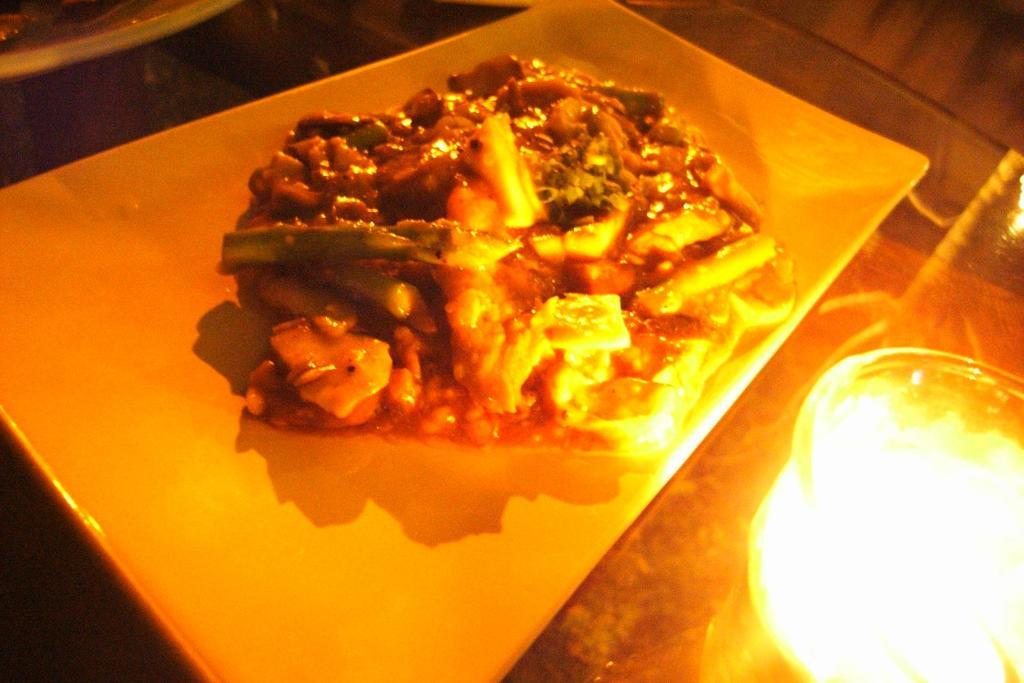What is on the tray in the image? There is food on a tray in the image. What else can be seen in the background of the image? There are objects on a table in the background of the image. Can you describe the lighting in the image? There is a light visible in the image. How many dogs are sitting next to the queen in the image? There are no dogs or queens present in the image. What type of chain is being used to secure the food on the tray? There is no chain visible in the image; the food is simply on the tray. 